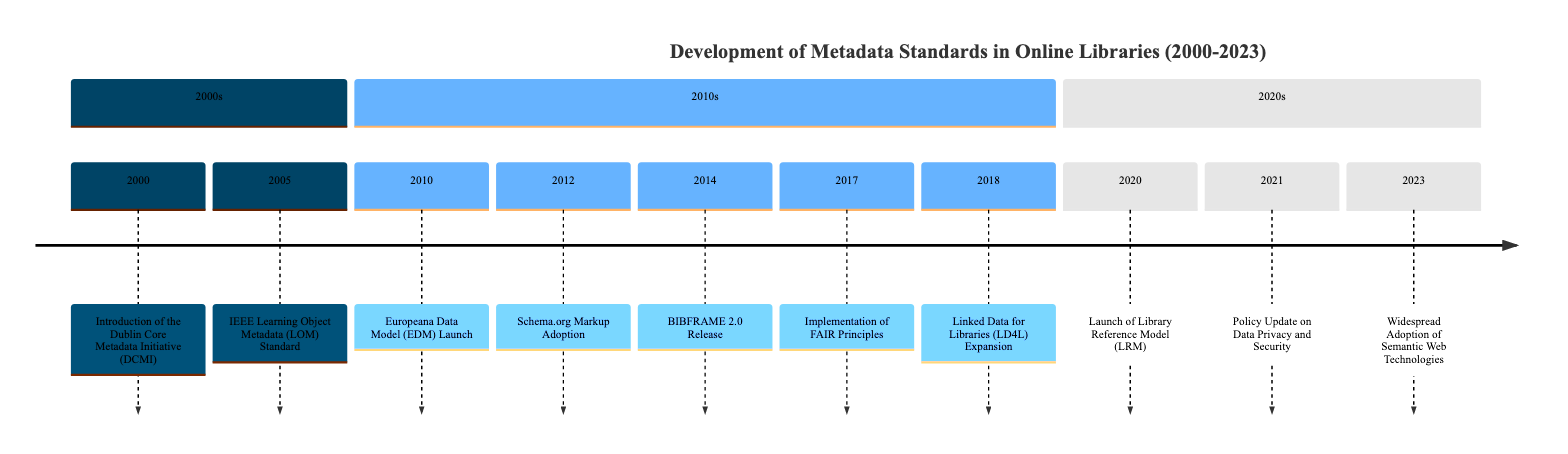What event introduced the Dublin Core Metadata Initiative? The diagram specifies that the Dublin Core Metadata Initiative (DCMI) was introduced in the year 2000, as indicated by the node representing this event.
Answer: Introduction of the Dublin Core Metadata Initiative (DCMI) How many key events occurred in the 2010s? By reviewing the timeline, we count the events listed under the 2010s section, which are six in total: Europeana Data Model Launch, Schema.org Markup Adoption, BIBFRAME 2.0 Release, Implementation of FAIR Principles, and Linked Data for Libraries Expansion.
Answer: 6 What year did the BIBFRAME 2.0 Release occur? The BIBFRAME 2.0 Release event is noted in the 2014 section of the timeline. We can see the year mentioned next to this event in the diagram.
Answer: 2014 Which framework was released to replace MARC standards? The diagram shows that BIBFRAME 2.0 was released to replace MARC standards, and it clearly links this information to the event that took place in 2014.
Answer: BIBFRAME 2.0 What principle was implemented by online libraries in 2017? The timeline indicates that in 2017, online libraries began the implementation of the FAIR Principles. This is highlighted as an important event within the 2010s section of the diagram.
Answer: Implementation of FAIR Principles What significant policy update occurred in 2021? The diagram clearly states that in 2021, there was a policy update regarding data privacy and security, which is specified under that year's event.
Answer: Policy Update on Data Privacy and Security In what year did libraries widely adopt Semantic Web Technologies? The timeline shows that the widespread adoption of Semantic Web Technologies took place in 2023, as indicated by the specific node representing this event.
Answer: 2023 How did the 2020s events differ from the 2010s in focus? Looking across both sections, the 2020s events emphasize frameworks and policy updates, while the 2010s are more centered around specific metadata standard developments and adoptions. This reflects a shift from technical developments to regulatory considerations.
Answer: Shift in focus to frameworks and regulations 